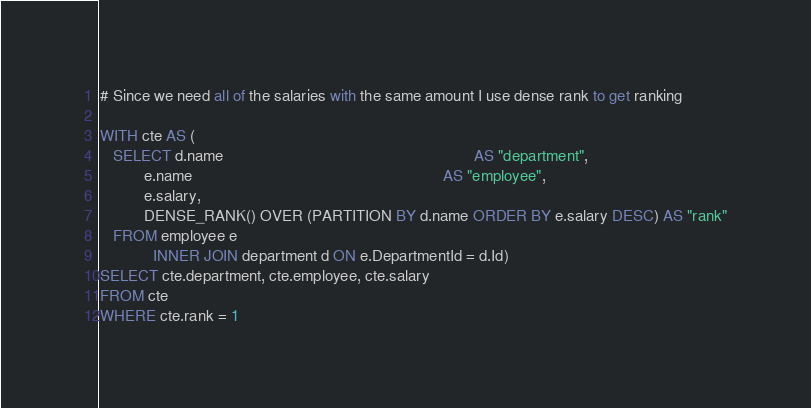<code> <loc_0><loc_0><loc_500><loc_500><_SQL_># Since we need all of the salaries with the same amount I use dense rank to get ranking

WITH cte AS (
   SELECT d.name                                                         AS "department",
          e.name                                                         AS "employee",
          e.salary,
          DENSE_RANK() OVER (PARTITION BY d.name ORDER BY e.salary DESC) AS "rank"
   FROM employee e
            INNER JOIN department d ON e.DepartmentId = d.Id)
SELECT cte.department, cte.employee, cte.salary
FROM cte
WHERE cte.rank = 1
</code> 